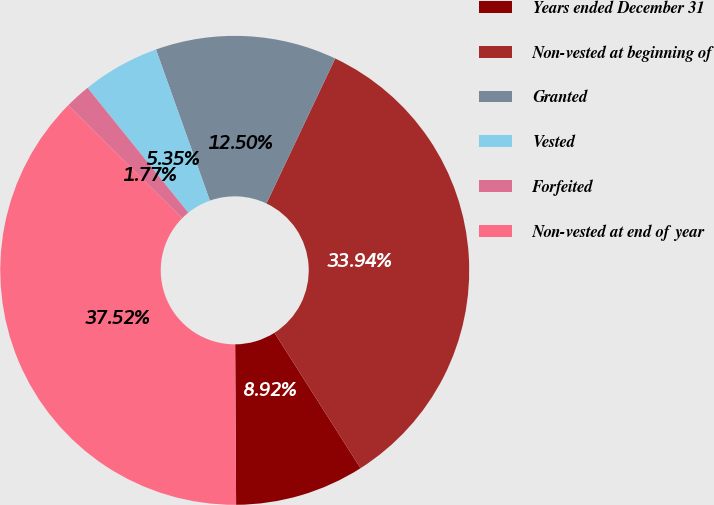Convert chart to OTSL. <chart><loc_0><loc_0><loc_500><loc_500><pie_chart><fcel>Years ended December 31<fcel>Non-vested at beginning of<fcel>Granted<fcel>Vested<fcel>Forfeited<fcel>Non-vested at end of year<nl><fcel>8.92%<fcel>33.94%<fcel>12.5%<fcel>5.35%<fcel>1.77%<fcel>37.52%<nl></chart> 